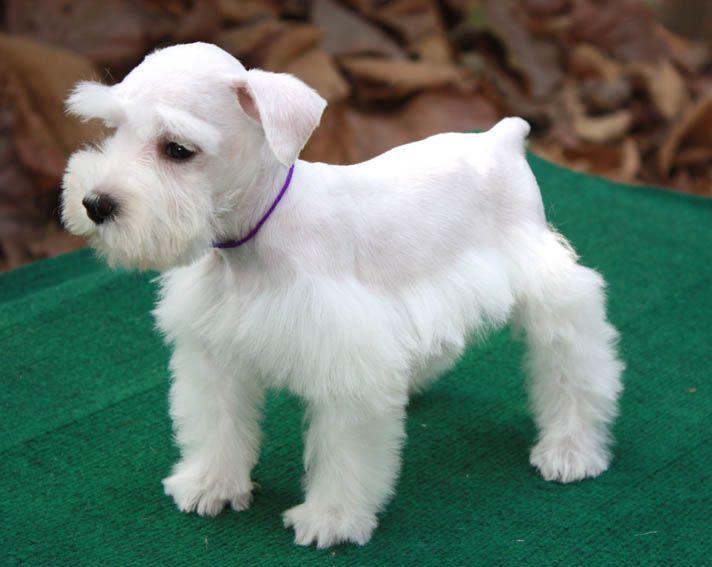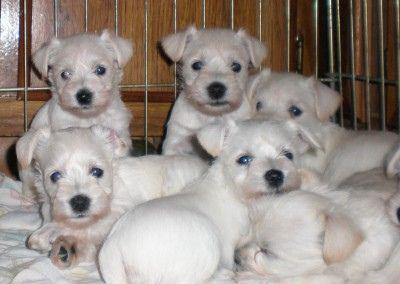The first image is the image on the left, the second image is the image on the right. For the images displayed, is the sentence "Each image contains one white dog, and the dog on the right is posed by striped fabric." factually correct? Answer yes or no. No. 